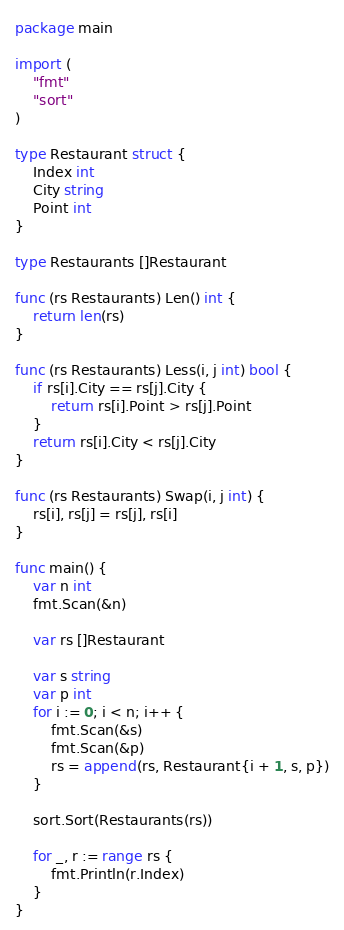Convert code to text. <code><loc_0><loc_0><loc_500><loc_500><_Go_>package main

import (
	"fmt"
	"sort"
)

type Restaurant struct {
	Index int
	City string
	Point int
}

type Restaurants []Restaurant

func (rs Restaurants) Len() int {
	return len(rs)
}

func (rs Restaurants) Less(i, j int) bool {
	if rs[i].City == rs[j].City {
		return rs[i].Point > rs[j].Point
	}
	return rs[i].City < rs[j].City
}

func (rs Restaurants) Swap(i, j int) {
	rs[i], rs[j] = rs[j], rs[i]
}

func main() {
	var n int
	fmt.Scan(&n)

	var rs []Restaurant

	var s string
	var p int
	for i := 0; i < n; i++ {
		fmt.Scan(&s)
		fmt.Scan(&p)
		rs = append(rs, Restaurant{i + 1, s, p})
	}

	sort.Sort(Restaurants(rs))

	for _, r := range rs {
		fmt.Println(r.Index)
	}
}</code> 